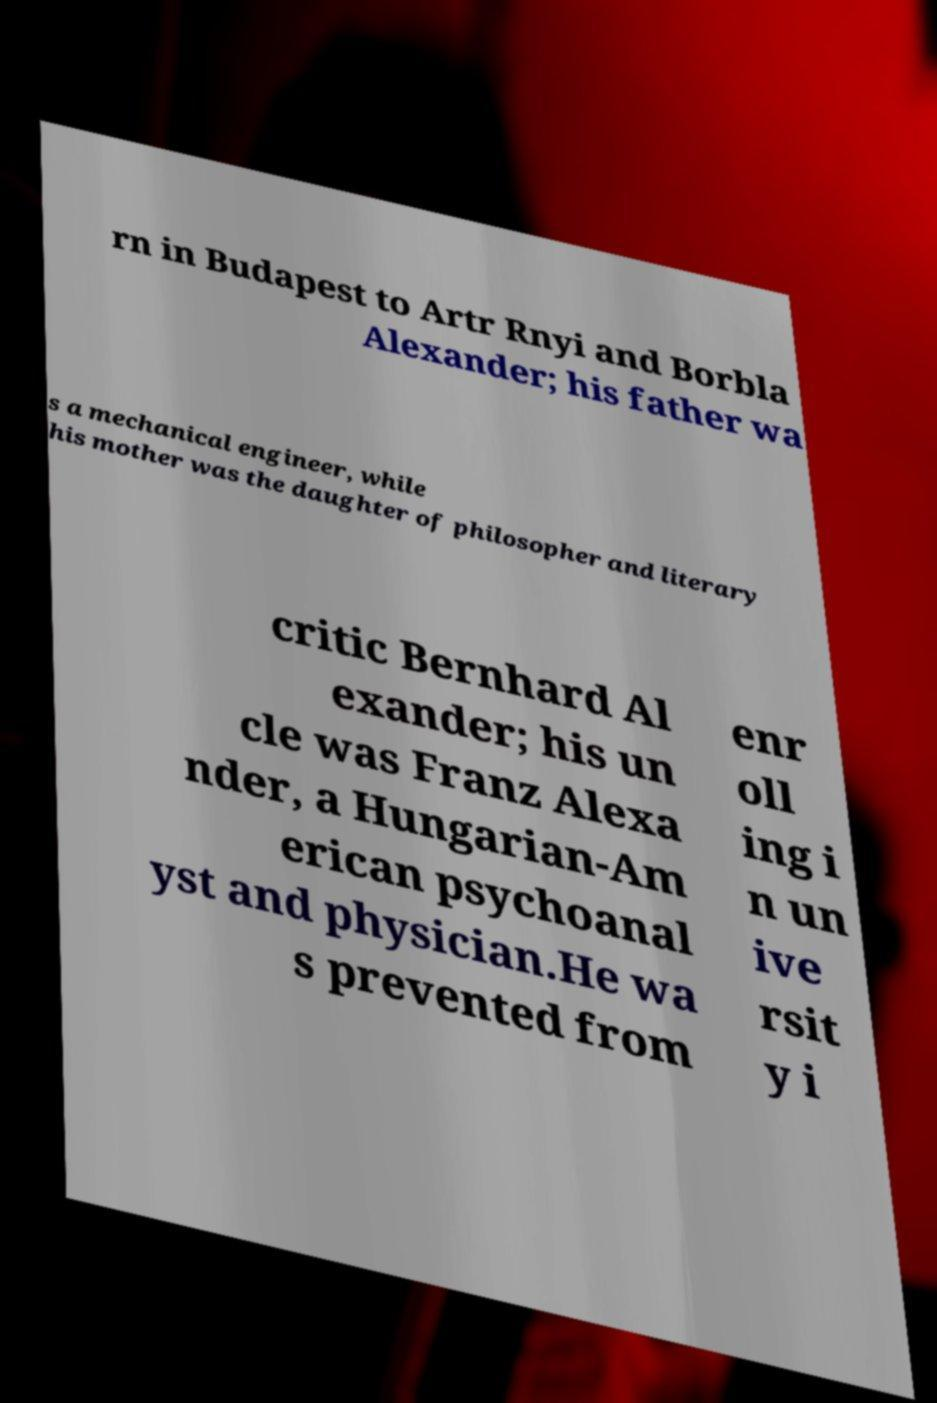Can you read and provide the text displayed in the image?This photo seems to have some interesting text. Can you extract and type it out for me? rn in Budapest to Artr Rnyi and Borbla Alexander; his father wa s a mechanical engineer, while his mother was the daughter of philosopher and literary critic Bernhard Al exander; his un cle was Franz Alexa nder, a Hungarian-Am erican psychoanal yst and physician.He wa s prevented from enr oll ing i n un ive rsit y i 